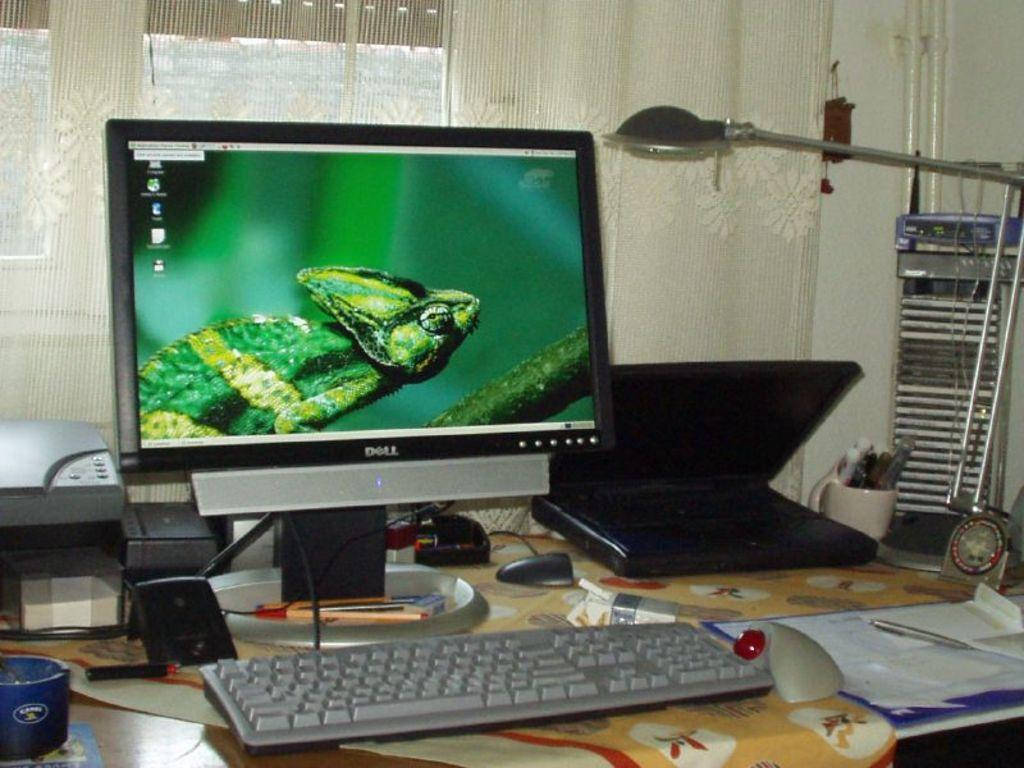Provide a one-sentence caption for the provided image. a desktop computer with a iguana on the display screen. 